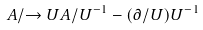<formula> <loc_0><loc_0><loc_500><loc_500>A / \rightarrow U A / U ^ { - 1 } - ( \partial / U ) U ^ { - 1 }</formula> 